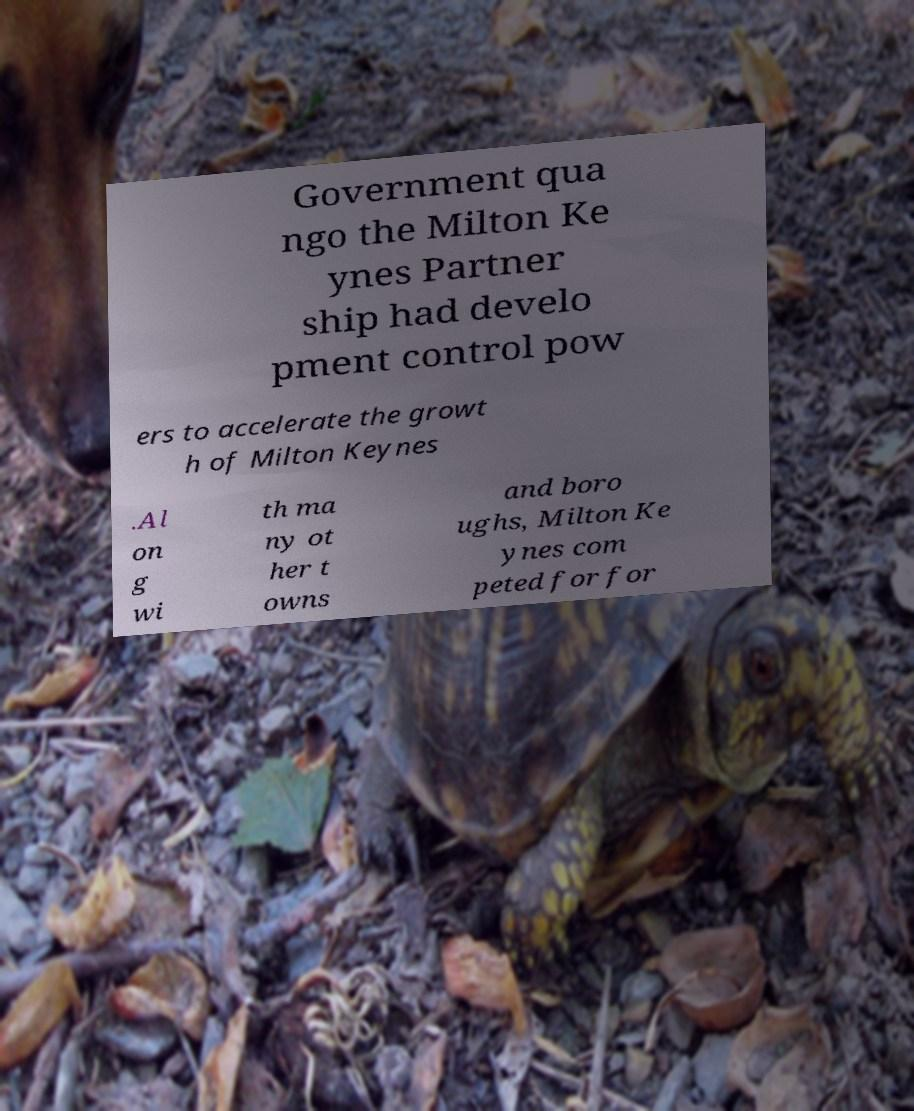Please identify and transcribe the text found in this image. Government qua ngo the Milton Ke ynes Partner ship had develo pment control pow ers to accelerate the growt h of Milton Keynes .Al on g wi th ma ny ot her t owns and boro ughs, Milton Ke ynes com peted for for 